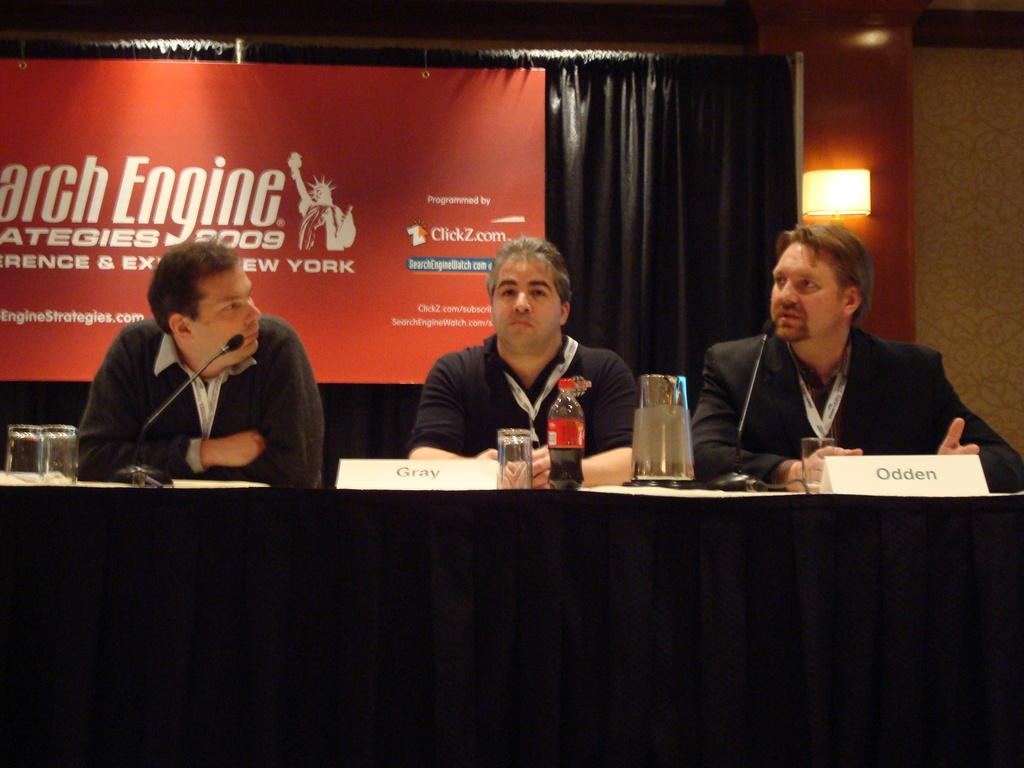<image>
Share a concise interpretation of the image provided. Three people in front of a black table with a sign that says Gray and Odden. 